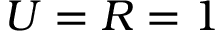Convert formula to latex. <formula><loc_0><loc_0><loc_500><loc_500>U = R = 1</formula> 